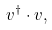<formula> <loc_0><loc_0><loc_500><loc_500>v ^ { \dagger } \cdot v ,</formula> 